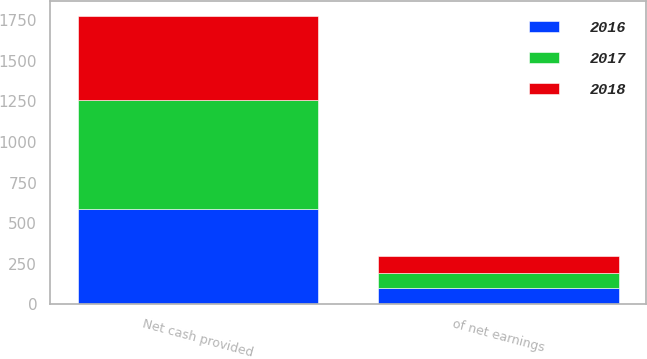Convert chart. <chart><loc_0><loc_0><loc_500><loc_500><stacked_bar_chart><ecel><fcel>Net cash provided<fcel>of net earnings<nl><fcel>2017<fcel>674.2<fcel>89.7<nl><fcel>2016<fcel>585.2<fcel>101.1<nl><fcel>2018<fcel>519.9<fcel>104.1<nl></chart> 